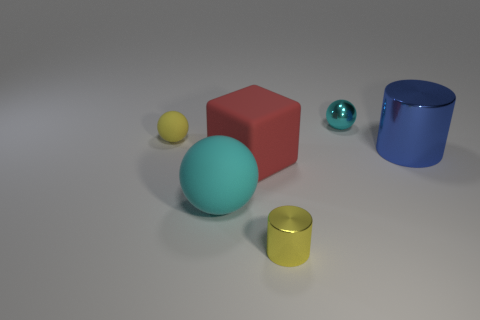Subtract all small balls. How many balls are left? 1 Add 1 small purple matte balls. How many objects exist? 7 Subtract all yellow cylinders. How many cylinders are left? 1 Subtract all blocks. How many objects are left? 5 Subtract all green cylinders. Subtract all red cubes. How many cylinders are left? 2 Subtract all green cubes. How many cyan spheres are left? 2 Subtract all small cyan matte objects. Subtract all tiny yellow cylinders. How many objects are left? 5 Add 1 tiny yellow metal cylinders. How many tiny yellow metal cylinders are left? 2 Add 2 metal objects. How many metal objects exist? 5 Subtract 0 purple cubes. How many objects are left? 6 